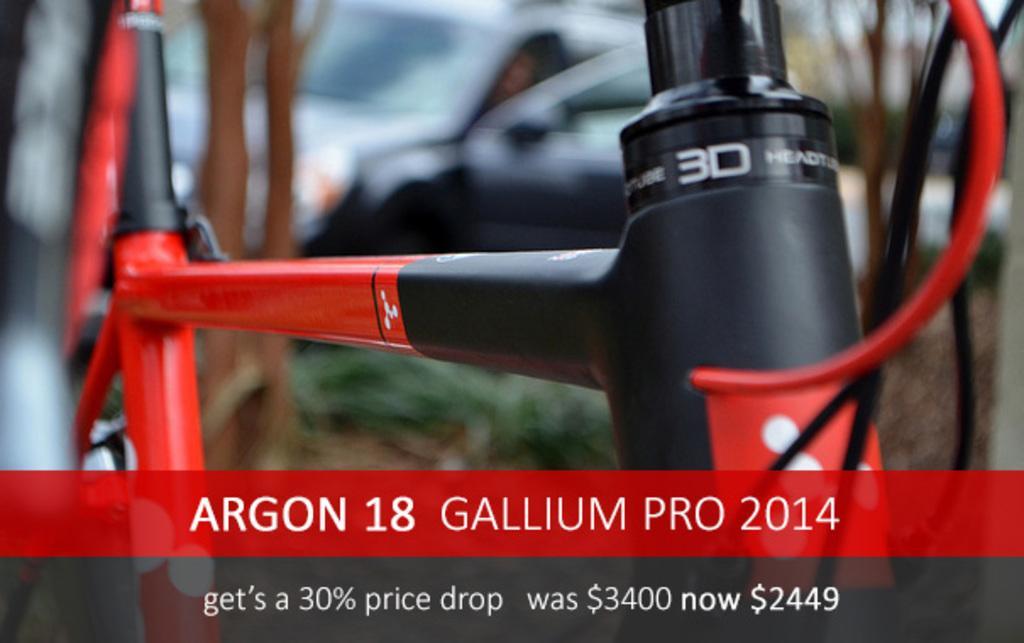In one or two sentences, can you explain what this image depicts? In this image I can see a part of a bicycle. I can see some text written on it. In the background, I can see a car. 